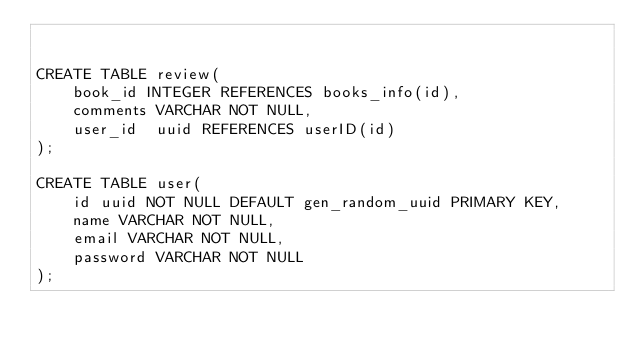<code> <loc_0><loc_0><loc_500><loc_500><_SQL_>

CREATE TABLE review(
    book_id INTEGER REFERENCES books_info(id),
    comments VARCHAR NOT NULL,
    user_id  uuid REFERENCES userID(id)
);

CREATE TABLE user(
    id uuid NOT NULL DEFAULT gen_random_uuid PRIMARY KEY,
    name VARCHAR NOT NULL,
    email VARCHAR NOT NULL,
    password VARCHAR NOT NULL
);




</code> 